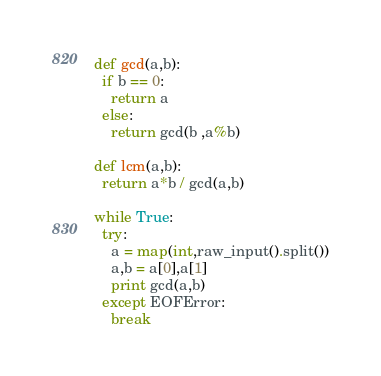<code> <loc_0><loc_0><loc_500><loc_500><_Python_>def gcd(a,b):
  if b == 0:
    return a
  else:
    return gcd(b ,a%b)

def lcm(a,b):
  return a*b / gcd(a,b)

while True:
  try:
    a = map(int,raw_input().split())
    a,b = a[0],a[1]
    print gcd(a,b)
  except EOFError:
    break</code> 